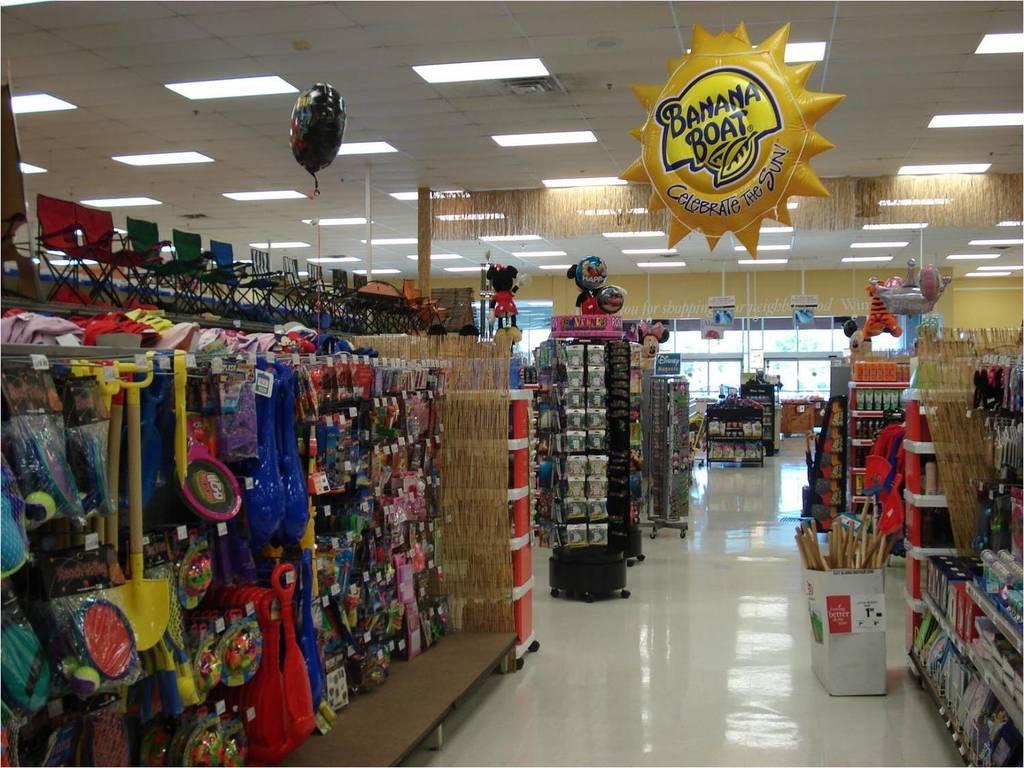What kind of boat is on the inflatable sun?
Your response must be concise. Banana. What is the catchphrase under the banana boat sign?
Give a very brief answer. Celebrate the sun. 